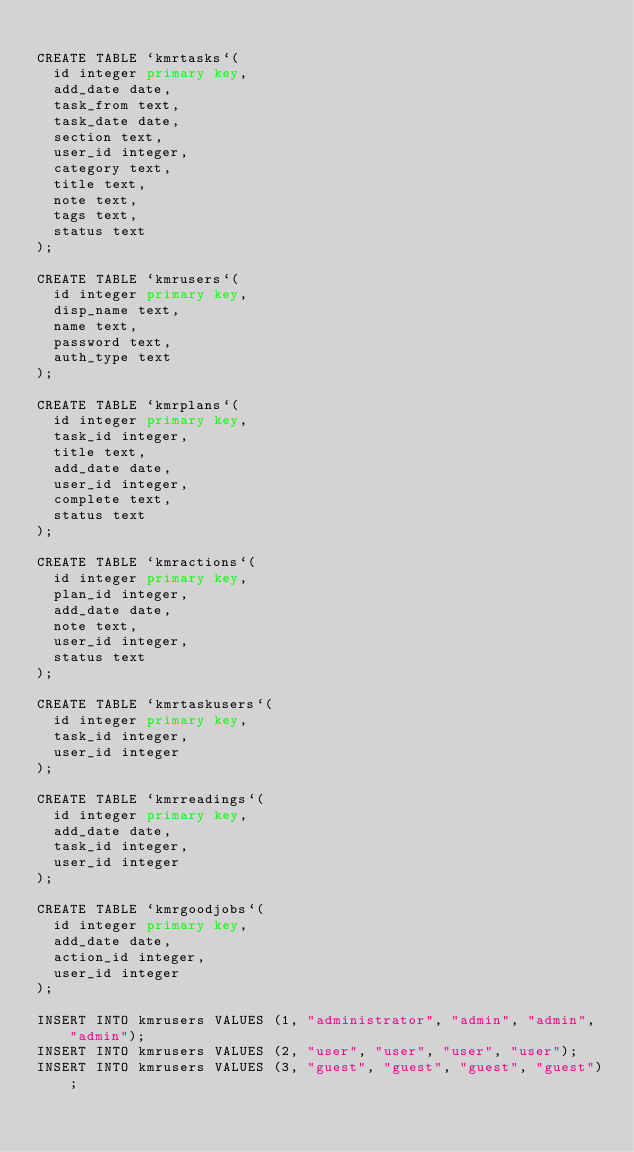Convert code to text. <code><loc_0><loc_0><loc_500><loc_500><_SQL_>
CREATE TABLE `kmrtasks`(
  id integer primary key,
  add_date date,
  task_from text,
  task_date date,
  section text,
  user_id integer,
  category text,
  title text,
  note text,
  tags text,
  status text
);

CREATE TABLE `kmrusers`(
  id integer primary key,
  disp_name text,
  name text,
  password text,
  auth_type text
);

CREATE TABLE `kmrplans`(
  id integer primary key,
  task_id integer,
  title text,
  add_date date,
  user_id integer,
  complete text,
  status text
);

CREATE TABLE `kmractions`(
  id integer primary key,
  plan_id integer,
  add_date date,
  note text,
  user_id integer,
  status text
);

CREATE TABLE `kmrtaskusers`(
  id integer primary key,
  task_id integer,
  user_id integer
);

CREATE TABLE `kmrreadings`(
  id integer primary key,
  add_date date,
  task_id integer,
  user_id integer
);

CREATE TABLE `kmrgoodjobs`(
  id integer primary key,
  add_date date,
  action_id integer,
  user_id integer
);

INSERT INTO kmrusers VALUES (1, "administrator", "admin", "admin", "admin");
INSERT INTO kmrusers VALUES (2, "user", "user", "user", "user");
INSERT INTO kmrusers VALUES (3, "guest", "guest", "guest", "guest");
</code> 